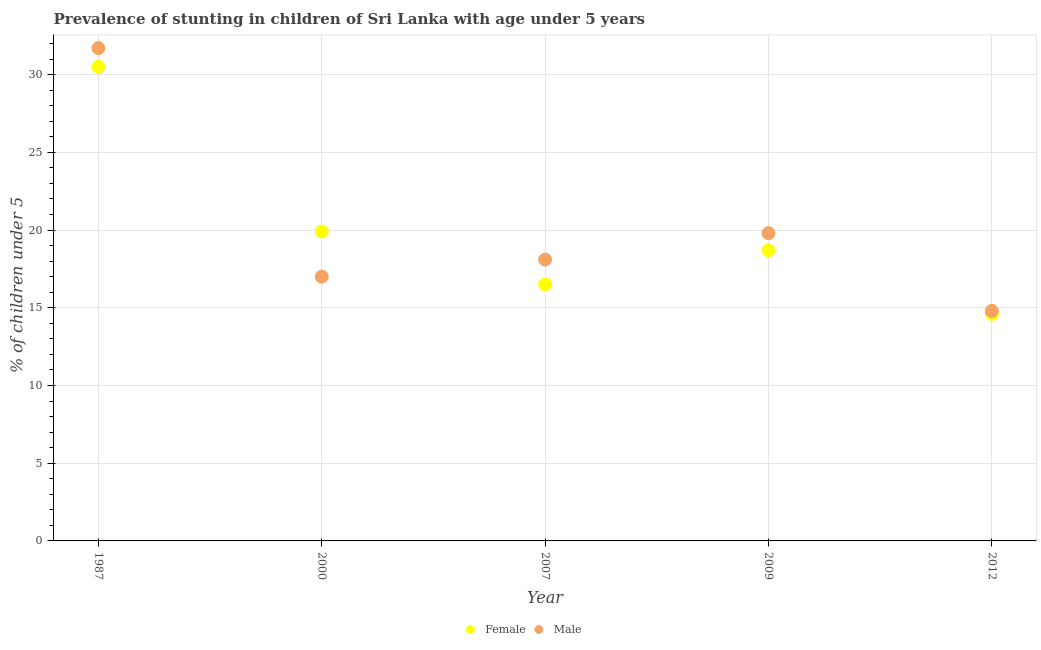How many different coloured dotlines are there?
Provide a succinct answer. 2. Across all years, what is the maximum percentage of stunted female children?
Keep it short and to the point. 30.5. Across all years, what is the minimum percentage of stunted male children?
Make the answer very short. 14.8. What is the total percentage of stunted female children in the graph?
Give a very brief answer. 100.2. What is the difference between the percentage of stunted male children in 1987 and that in 2009?
Provide a short and direct response. 11.9. What is the difference between the percentage of stunted female children in 2007 and the percentage of stunted male children in 2009?
Your answer should be compact. -3.3. What is the average percentage of stunted female children per year?
Provide a succinct answer. 20.04. In the year 2000, what is the difference between the percentage of stunted female children and percentage of stunted male children?
Your answer should be very brief. 2.9. What is the ratio of the percentage of stunted female children in 1987 to that in 2012?
Provide a short and direct response. 2.09. Is the difference between the percentage of stunted male children in 2000 and 2012 greater than the difference between the percentage of stunted female children in 2000 and 2012?
Offer a very short reply. No. What is the difference between the highest and the second highest percentage of stunted male children?
Ensure brevity in your answer.  11.9. What is the difference between the highest and the lowest percentage of stunted female children?
Give a very brief answer. 15.9. In how many years, is the percentage of stunted male children greater than the average percentage of stunted male children taken over all years?
Ensure brevity in your answer.  1. Is the sum of the percentage of stunted female children in 1987 and 2000 greater than the maximum percentage of stunted male children across all years?
Your response must be concise. Yes. Does the percentage of stunted male children monotonically increase over the years?
Provide a succinct answer. No. Is the percentage of stunted male children strictly greater than the percentage of stunted female children over the years?
Your answer should be compact. No. Is the percentage of stunted male children strictly less than the percentage of stunted female children over the years?
Give a very brief answer. No. What is the difference between two consecutive major ticks on the Y-axis?
Give a very brief answer. 5. Are the values on the major ticks of Y-axis written in scientific E-notation?
Provide a succinct answer. No. Does the graph contain grids?
Provide a short and direct response. Yes. How many legend labels are there?
Offer a very short reply. 2. What is the title of the graph?
Offer a very short reply. Prevalence of stunting in children of Sri Lanka with age under 5 years. Does "Import" appear as one of the legend labels in the graph?
Your response must be concise. No. What is the label or title of the X-axis?
Give a very brief answer. Year. What is the label or title of the Y-axis?
Your answer should be very brief.  % of children under 5. What is the  % of children under 5 of Female in 1987?
Ensure brevity in your answer.  30.5. What is the  % of children under 5 in Male in 1987?
Offer a terse response. 31.7. What is the  % of children under 5 of Female in 2000?
Offer a terse response. 19.9. What is the  % of children under 5 in Male in 2007?
Offer a very short reply. 18.1. What is the  % of children under 5 of Female in 2009?
Keep it short and to the point. 18.7. What is the  % of children under 5 in Male in 2009?
Give a very brief answer. 19.8. What is the  % of children under 5 in Female in 2012?
Provide a short and direct response. 14.6. What is the  % of children under 5 of Male in 2012?
Provide a short and direct response. 14.8. Across all years, what is the maximum  % of children under 5 in Female?
Your response must be concise. 30.5. Across all years, what is the maximum  % of children under 5 in Male?
Your response must be concise. 31.7. Across all years, what is the minimum  % of children under 5 in Female?
Make the answer very short. 14.6. Across all years, what is the minimum  % of children under 5 in Male?
Provide a short and direct response. 14.8. What is the total  % of children under 5 of Female in the graph?
Your answer should be very brief. 100.2. What is the total  % of children under 5 of Male in the graph?
Give a very brief answer. 101.4. What is the difference between the  % of children under 5 in Female in 1987 and that in 2000?
Offer a terse response. 10.6. What is the difference between the  % of children under 5 in Male in 1987 and that in 2000?
Provide a succinct answer. 14.7. What is the difference between the  % of children under 5 of Female in 1987 and that in 2007?
Your answer should be compact. 14. What is the difference between the  % of children under 5 in Male in 1987 and that in 2007?
Offer a terse response. 13.6. What is the difference between the  % of children under 5 of Female in 1987 and that in 2009?
Your answer should be compact. 11.8. What is the difference between the  % of children under 5 in Female in 1987 and that in 2012?
Offer a terse response. 15.9. What is the difference between the  % of children under 5 of Male in 1987 and that in 2012?
Provide a short and direct response. 16.9. What is the difference between the  % of children under 5 of Male in 2000 and that in 2012?
Your answer should be compact. 2.2. What is the difference between the  % of children under 5 of Female in 2007 and that in 2009?
Your answer should be compact. -2.2. What is the difference between the  % of children under 5 in Male in 2007 and that in 2009?
Your response must be concise. -1.7. What is the difference between the  % of children under 5 in Male in 2009 and that in 2012?
Offer a very short reply. 5. What is the difference between the  % of children under 5 of Female in 1987 and the  % of children under 5 of Male in 2009?
Ensure brevity in your answer.  10.7. What is the difference between the  % of children under 5 in Female in 2000 and the  % of children under 5 in Male in 2012?
Provide a short and direct response. 5.1. What is the difference between the  % of children under 5 in Female in 2007 and the  % of children under 5 in Male in 2009?
Your answer should be very brief. -3.3. What is the average  % of children under 5 of Female per year?
Provide a short and direct response. 20.04. What is the average  % of children under 5 of Male per year?
Offer a very short reply. 20.28. In the year 1987, what is the difference between the  % of children under 5 of Female and  % of children under 5 of Male?
Provide a short and direct response. -1.2. In the year 2000, what is the difference between the  % of children under 5 of Female and  % of children under 5 of Male?
Offer a very short reply. 2.9. In the year 2009, what is the difference between the  % of children under 5 of Female and  % of children under 5 of Male?
Give a very brief answer. -1.1. In the year 2012, what is the difference between the  % of children under 5 of Female and  % of children under 5 of Male?
Give a very brief answer. -0.2. What is the ratio of the  % of children under 5 in Female in 1987 to that in 2000?
Your answer should be compact. 1.53. What is the ratio of the  % of children under 5 of Male in 1987 to that in 2000?
Offer a terse response. 1.86. What is the ratio of the  % of children under 5 in Female in 1987 to that in 2007?
Your answer should be very brief. 1.85. What is the ratio of the  % of children under 5 of Male in 1987 to that in 2007?
Keep it short and to the point. 1.75. What is the ratio of the  % of children under 5 in Female in 1987 to that in 2009?
Provide a succinct answer. 1.63. What is the ratio of the  % of children under 5 of Male in 1987 to that in 2009?
Your response must be concise. 1.6. What is the ratio of the  % of children under 5 of Female in 1987 to that in 2012?
Provide a succinct answer. 2.09. What is the ratio of the  % of children under 5 in Male in 1987 to that in 2012?
Provide a short and direct response. 2.14. What is the ratio of the  % of children under 5 of Female in 2000 to that in 2007?
Provide a succinct answer. 1.21. What is the ratio of the  % of children under 5 in Male in 2000 to that in 2007?
Offer a very short reply. 0.94. What is the ratio of the  % of children under 5 in Female in 2000 to that in 2009?
Offer a terse response. 1.06. What is the ratio of the  % of children under 5 of Male in 2000 to that in 2009?
Your answer should be compact. 0.86. What is the ratio of the  % of children under 5 in Female in 2000 to that in 2012?
Offer a very short reply. 1.36. What is the ratio of the  % of children under 5 of Male in 2000 to that in 2012?
Offer a terse response. 1.15. What is the ratio of the  % of children under 5 of Female in 2007 to that in 2009?
Offer a terse response. 0.88. What is the ratio of the  % of children under 5 in Male in 2007 to that in 2009?
Offer a very short reply. 0.91. What is the ratio of the  % of children under 5 of Female in 2007 to that in 2012?
Provide a short and direct response. 1.13. What is the ratio of the  % of children under 5 in Male in 2007 to that in 2012?
Your answer should be compact. 1.22. What is the ratio of the  % of children under 5 of Female in 2009 to that in 2012?
Your answer should be compact. 1.28. What is the ratio of the  % of children under 5 in Male in 2009 to that in 2012?
Keep it short and to the point. 1.34. What is the difference between the highest and the second highest  % of children under 5 of Male?
Offer a very short reply. 11.9. What is the difference between the highest and the lowest  % of children under 5 in Male?
Your answer should be compact. 16.9. 